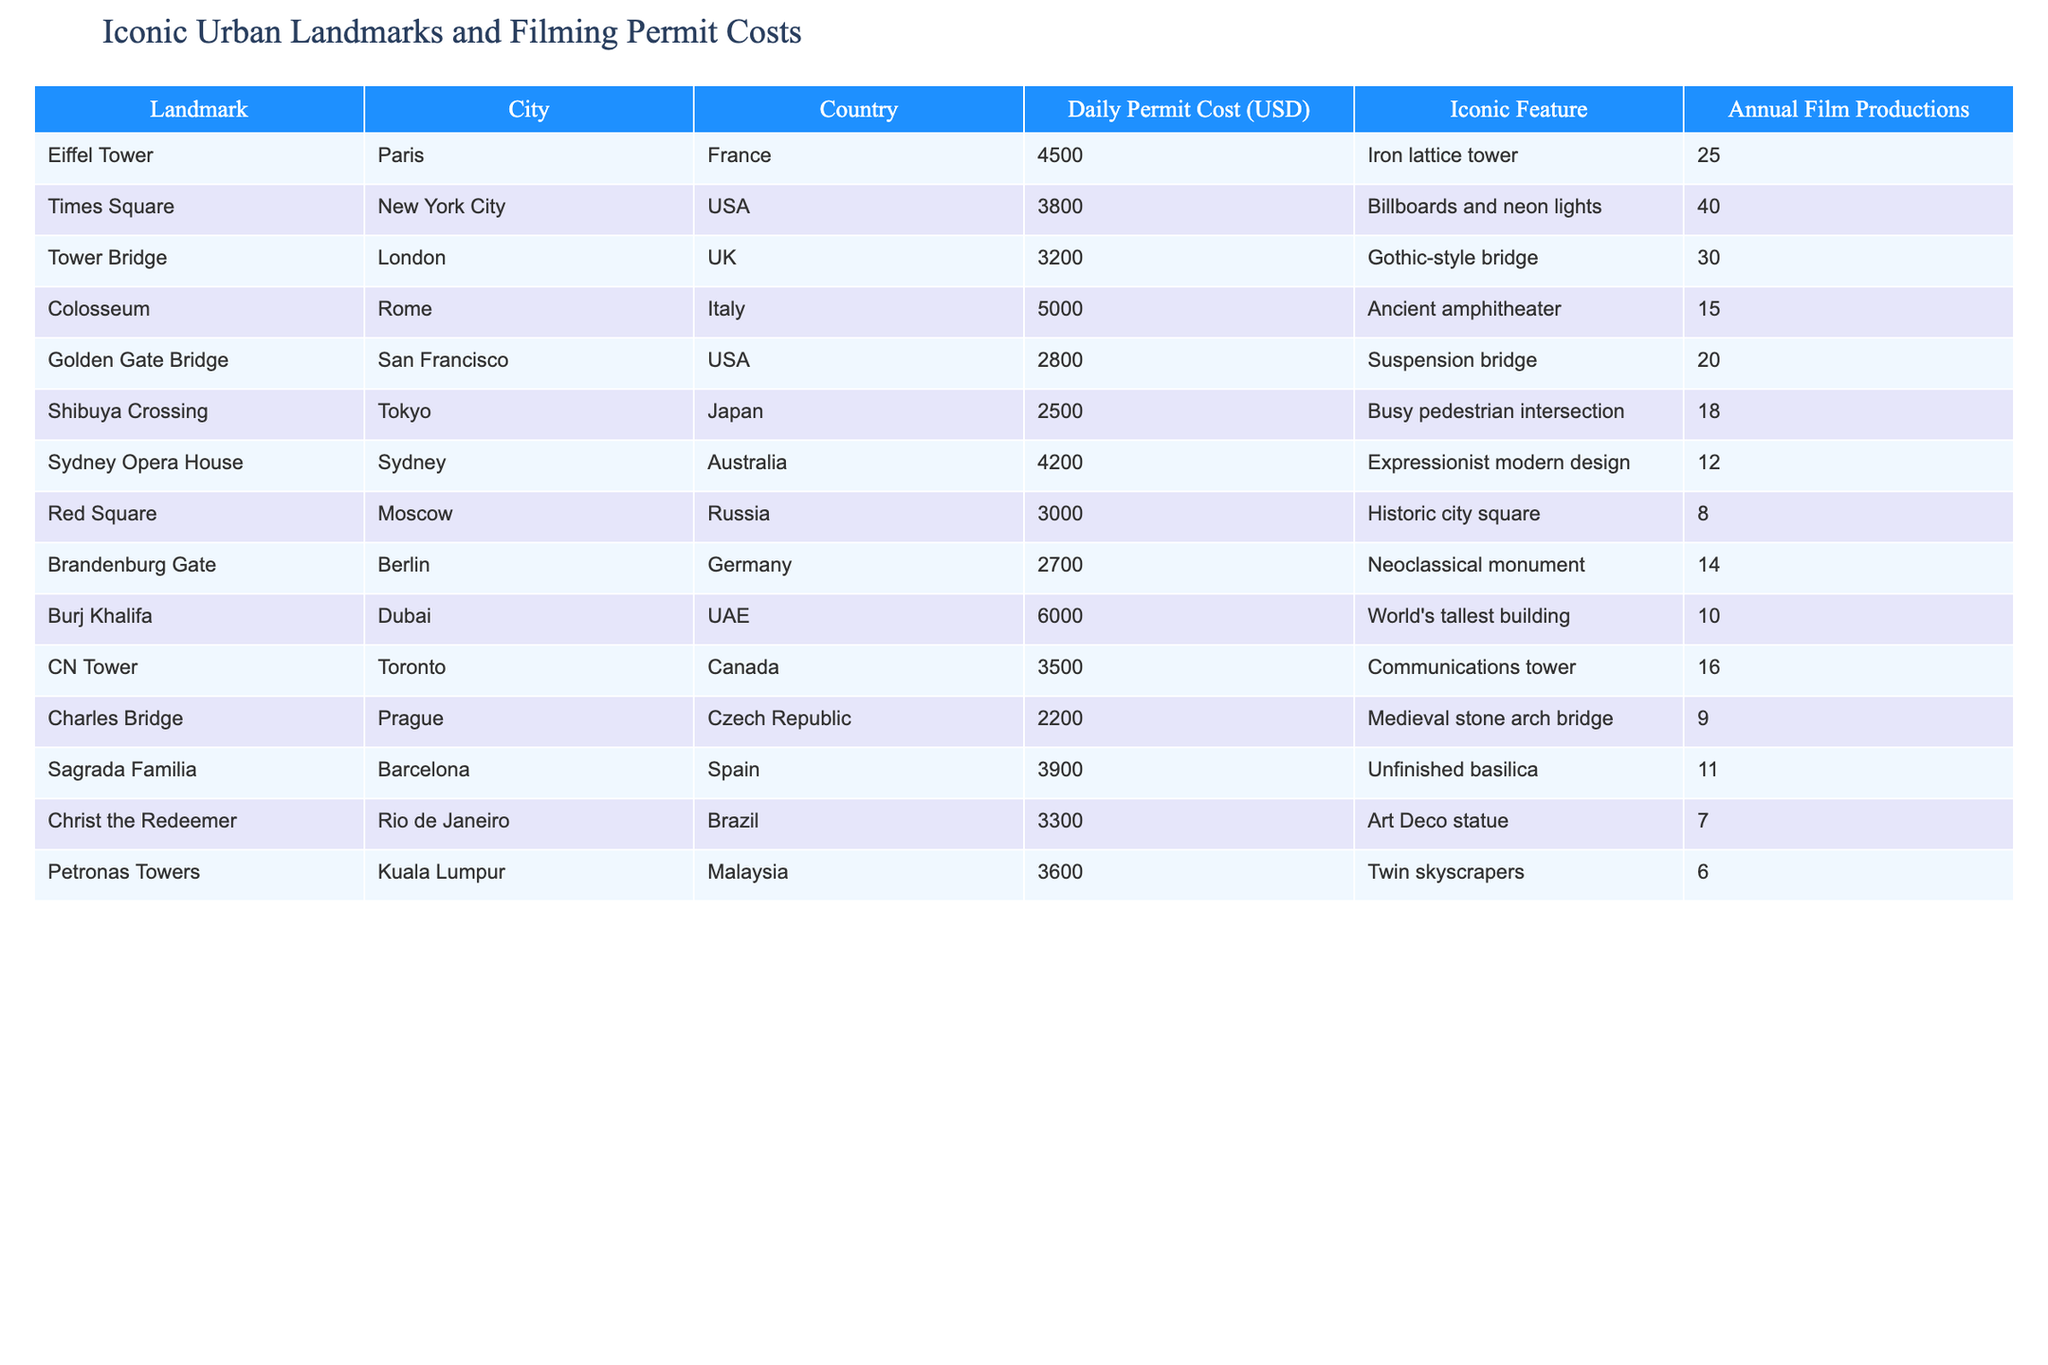What is the daily permit cost for filming at the Eiffel Tower? The table shows that the daily permit cost for the Eiffel Tower is listed under the "Daily Permit Cost (USD)" column. Looking at that row, the value is 4500.
Answer: 4500 Which landmark has the highest annual film productions? To find this, we look at the "Annual Film Productions" column, where the maximum value is 40, corresponding to Times Square.
Answer: Times Square What is the average daily permit cost of the landmarks listed? First, we sum up all the daily permit costs: 4500 + 3800 + 3200 + 5000 + 2800 + 2500 + 4200 + 3000 + 2700 + 6000 + 3500 + 2200 + 3900 + 3300 + 3600 = 49300. There are 15 landmarks, so the average is 49300 / 15 ≈ 3286.67.
Answer: 3286.67 Is the daily permit cost for the Burj Khalifa higher than 5000? According to the table, the daily permit cost for the Burj Khalifa is 6000, which is indeed higher than 5000.
Answer: Yes How many more film productions does Times Square have compared to the Sydney Opera House? The "Annual Film Productions" for Times Square is 40 and for the Sydney Opera House, it's 12. Therefore, the difference is 40 - 12 = 28.
Answer: 28 Which landmark has a lower daily permit cost: the Colosseum or the Golden Gate Bridge? The daily permit cost for the Colosseum is 5000 and for the Golden Gate Bridge is 2800. Since 2800 is less than 5000, the Golden Gate Bridge has a lower cost.
Answer: Golden Gate Bridge What is the total annual film production count for the landmarks in the USA? The USA landmarks in the table are Times Square (40), Golden Gate Bridge (20), and Burj Khalifa (10). Adding these together gives us 40 + 20 + 10 = 70.
Answer: 70 Which country's landmark has the most iconic feature that includes a statue? The only landmark with a statue as its iconic feature is the Christ the Redeemer in Brazil.
Answer: Brazil 